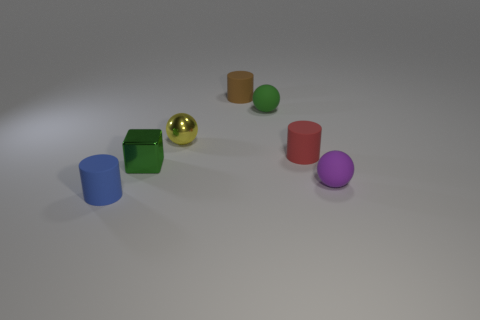Subtract all blue matte cylinders. How many cylinders are left? 2 Subtract all cubes. How many objects are left? 6 Subtract all yellow spheres. How many spheres are left? 2 Subtract 0 cyan cylinders. How many objects are left? 7 Subtract all gray spheres. Subtract all brown cylinders. How many spheres are left? 3 Subtract all gray cylinders. How many purple balls are left? 1 Subtract all purple objects. Subtract all tiny yellow things. How many objects are left? 5 Add 4 matte cylinders. How many matte cylinders are left? 7 Add 4 small brown matte cylinders. How many small brown matte cylinders exist? 5 Add 3 small green cubes. How many objects exist? 10 